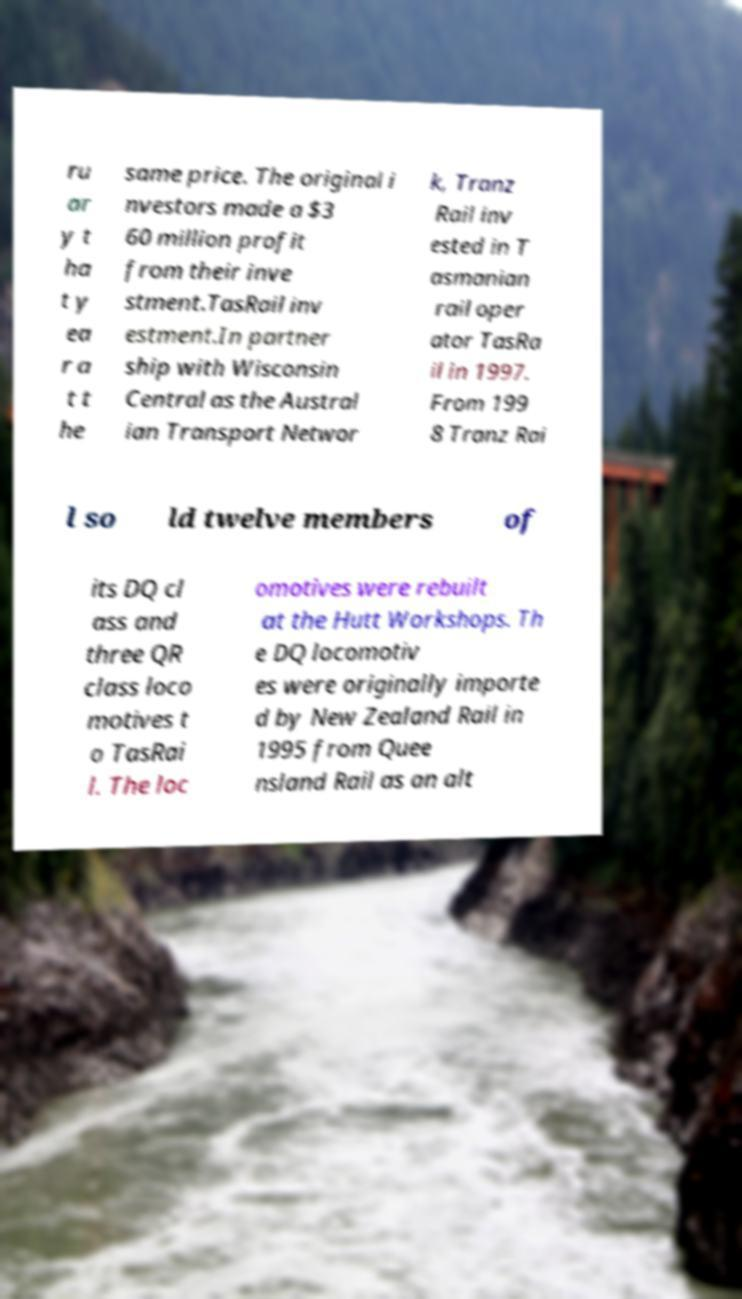Could you assist in decoding the text presented in this image and type it out clearly? ru ar y t ha t y ea r a t t he same price. The original i nvestors made a $3 60 million profit from their inve stment.TasRail inv estment.In partner ship with Wisconsin Central as the Austral ian Transport Networ k, Tranz Rail inv ested in T asmanian rail oper ator TasRa il in 1997. From 199 8 Tranz Rai l so ld twelve members of its DQ cl ass and three QR class loco motives t o TasRai l. The loc omotives were rebuilt at the Hutt Workshops. Th e DQ locomotiv es were originally importe d by New Zealand Rail in 1995 from Quee nsland Rail as an alt 